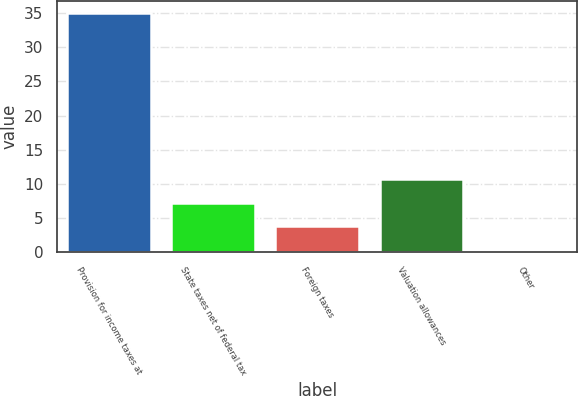<chart> <loc_0><loc_0><loc_500><loc_500><bar_chart><fcel>Provision for income taxes at<fcel>State taxes net of federal tax<fcel>Foreign taxes<fcel>Valuation allowances<fcel>Other<nl><fcel>35<fcel>7.24<fcel>3.77<fcel>10.71<fcel>0.3<nl></chart> 